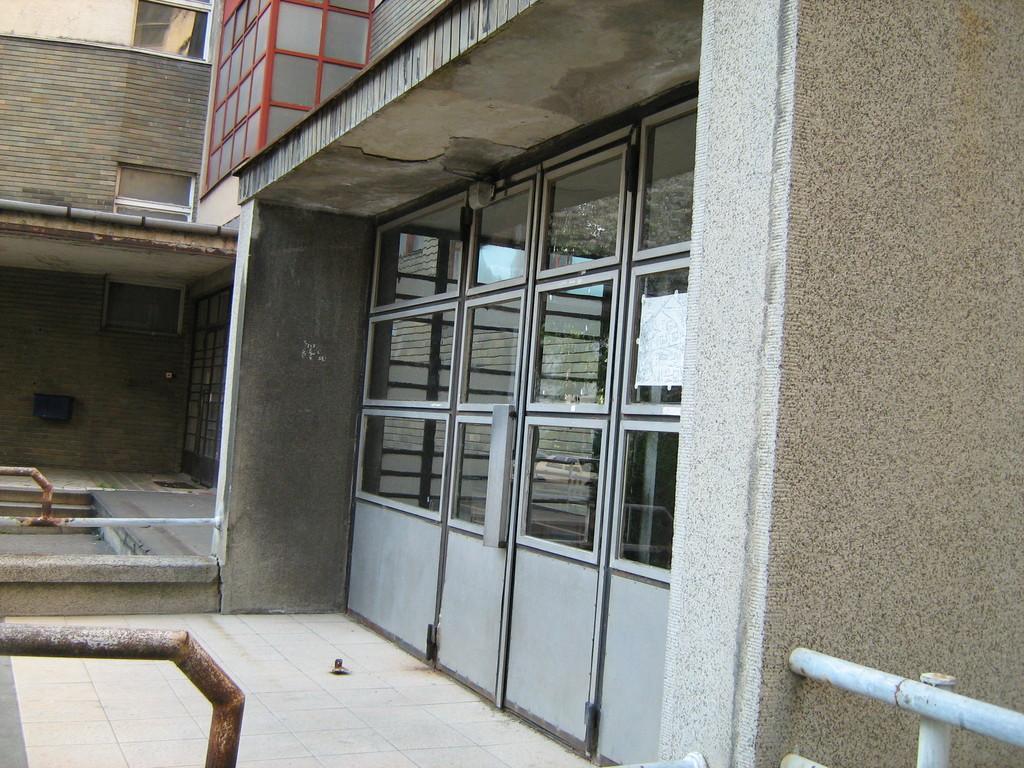Please provide a concise description of this image. In this image in the center there is a building and glass doors, at the bottom there are some pipes and iron rods and a walkway. On the right side there is a wall, in the center there is a gate and a doormat. 